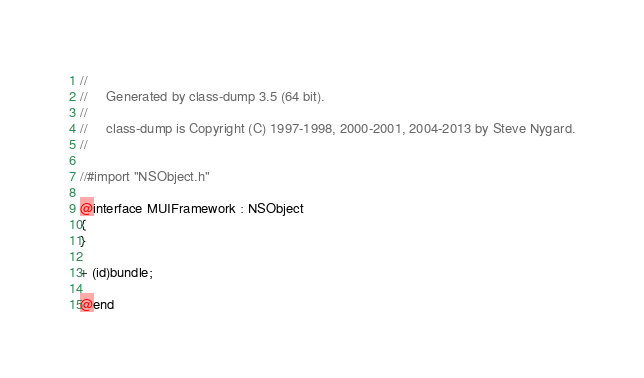<code> <loc_0><loc_0><loc_500><loc_500><_C_>//
//     Generated by class-dump 3.5 (64 bit).
//
//     class-dump is Copyright (C) 1997-1998, 2000-2001, 2004-2013 by Steve Nygard.
//

//#import "NSObject.h"

@interface MUIFramework : NSObject
{
}

+ (id)bundle;

@end

</code> 